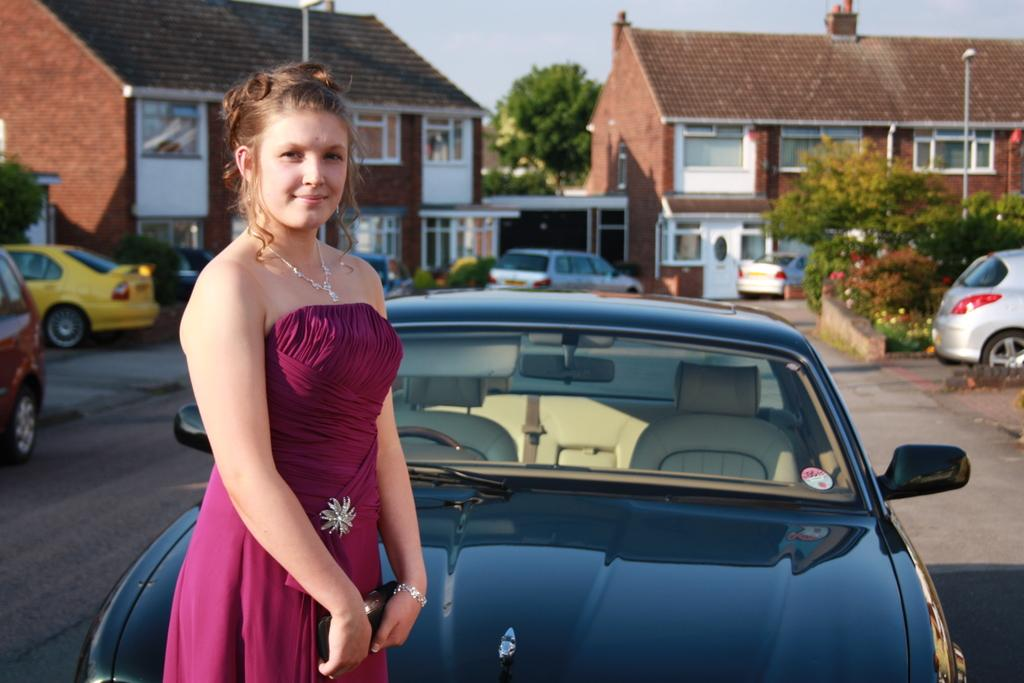What type of vehicles can be seen in the image? There are cars in the image. What other objects or structures are present in the image? There are trees and buildings in the image. Can you describe the person in the image? There is a woman standing in the front of the image. What is visible at the top of the image? The sky is visible at the top of the image. How many kittens are sitting on the trees in the image? There are no kittens present in the image; it features cars, trees, buildings, and a woman. What type of cakes are being served in the image? There is no mention of cakes in the image; it focuses on cars, trees, buildings, and a woman. 